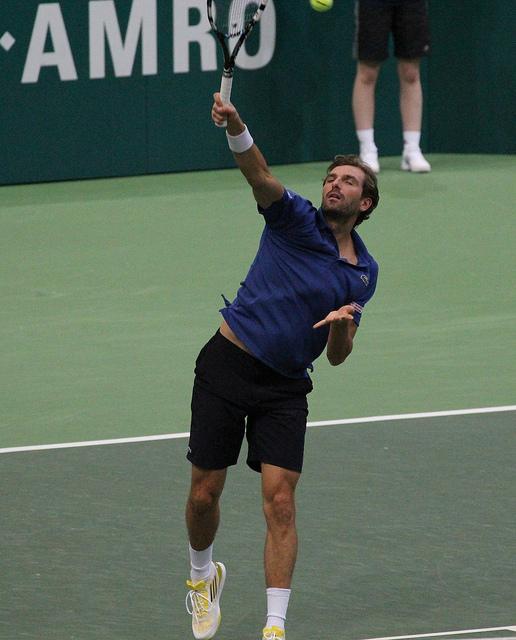What color is the trim on his shoes?
Quick response, please. Yellow. Is the player wearing a headband?
Be succinct. No. What brand of shirt is the man in the background wearing?
Give a very brief answer. Nike. What color are his shorts?
Concise answer only. Black. Did this player just hit a backhand or forehand shot?
Short answer required. Forehand. Which is the color of the racket?
Write a very short answer. Black. What color is his outfit?
Keep it brief. Blue and black. What brand is the man's shirt?
Short answer required. Adidas. What brand's symbol is on the purple shirt?
Quick response, please. Nike. What color is the man's shirt?
Short answer required. Blue. Is the player about to perform a backhand?
Keep it brief. No. Are the man's feet on the ground?
Concise answer only. Yes. What technique is demonstrated here?
Give a very brief answer. Serving. Is there a yellow chair in the background?
Keep it brief. No. Are either of his fists clenched?
Answer briefly. Yes. Are the man's eyes closed?
Short answer required. Yes. What color is this outfit?
Keep it brief. Blue and black. Which leg is in front?
Quick response, please. Left. 